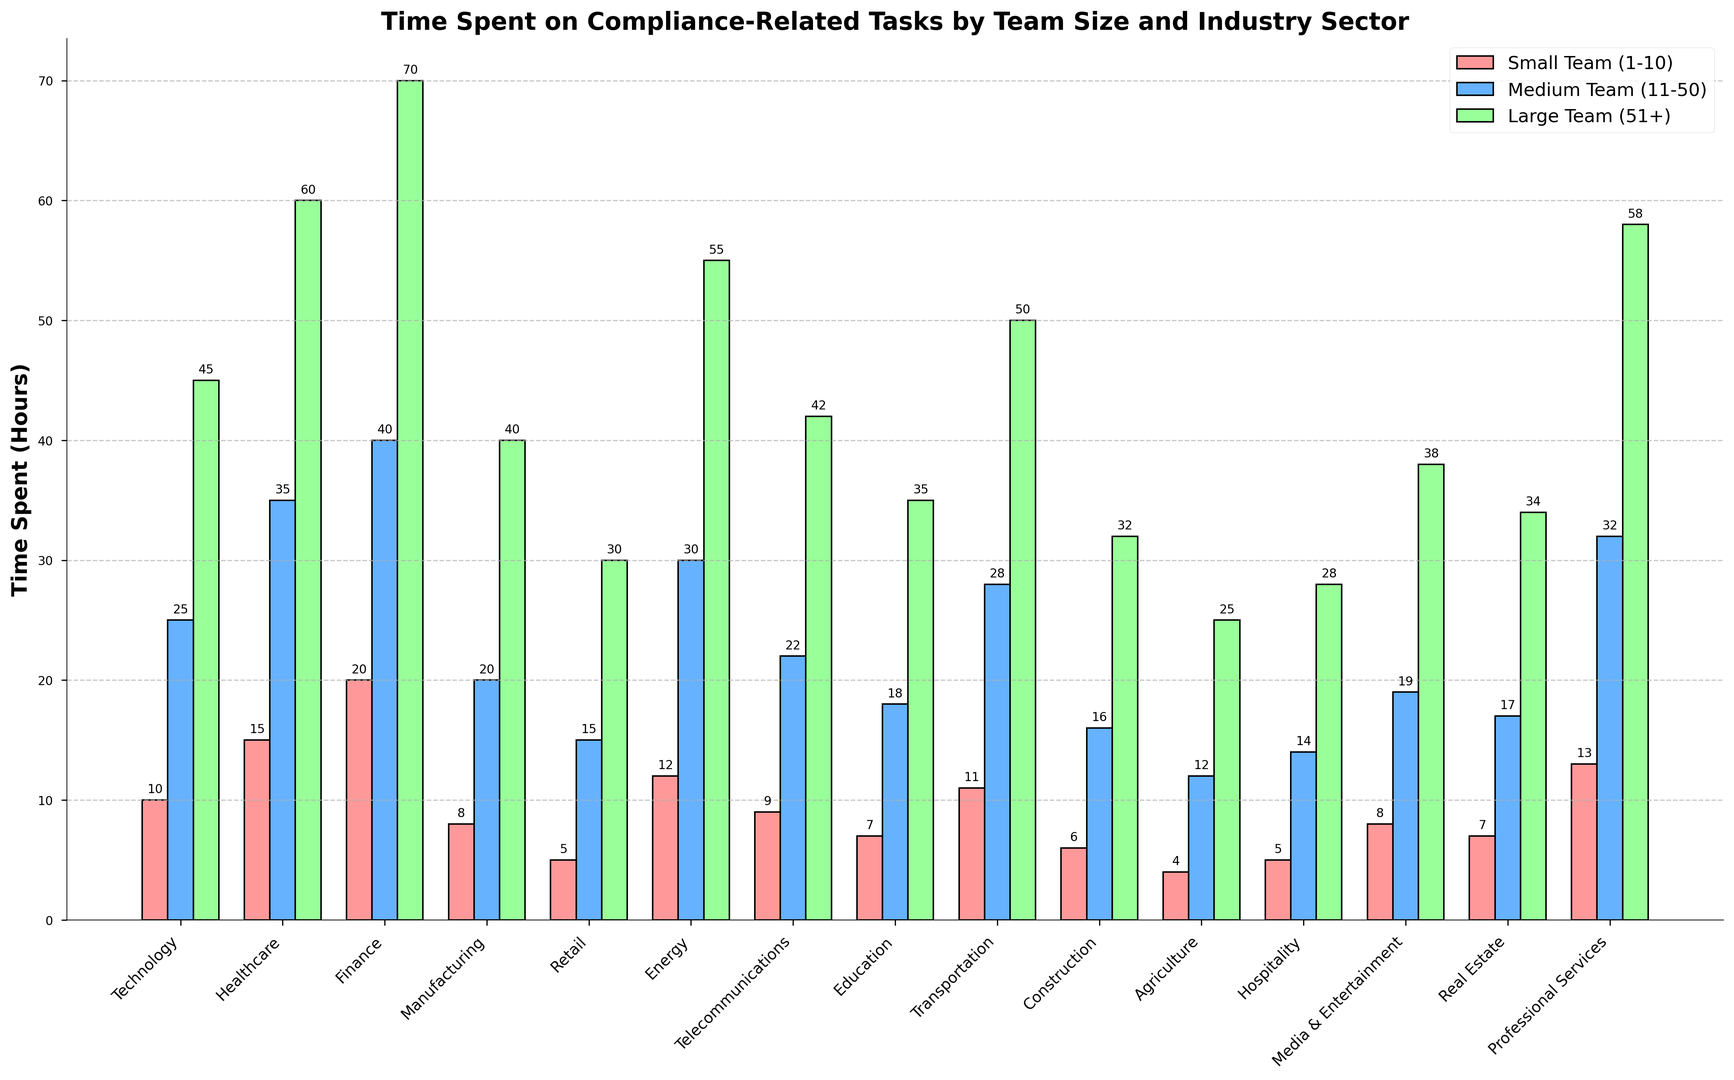What industry sector has the highest time spent on compliance-related tasks for large teams (51+)? In the plot, the bar representing large teams (51+) in the Finance sector is the tallest, indicating the highest time spent on compliance-related tasks.
Answer: Finance Which team size spends the most time on compliance-related tasks in the Retail sector? By comparing the three bars for the Retail sector, the bar representing large teams (51+) is the highest.
Answer: Large Team (51+) What is the difference in time spent on compliance-related tasks between small teams (1-10) and large teams (51+) in the Media & Entertainment sector? Locate the heights of the small teams and large teams' bars in the Media & Entertainment sector and subtract the small teams' bar height (8) from the large teams' bar height (38). Thus, 38 - 8 = 30.
Answer: 30 What is the average time spent on compliance-related tasks across all team sizes in the Telecommunications sector? Sum the bars in the Telecommunications sector: 9 (small) + 22 (medium) + 42 (large), then divide by the number of team sizes (3). The calculation is (9 + 22 + 42) / 3 = 24.33.
Answer: 24.33 Which sector has the least time spent on compliance-related tasks by medium teams (11-50)? Identify the shortest bar among the medium teams' bars, which is the Agriculture sector with a height of 12.
Answer: Agriculture In the Professional Services sector, how much more time does a large team spend on compliance than a small team? Subtract the height of the small teams' bar (13) from the large teams' bar (58) in the Professional Services sector. The calculation is 58 - 13 = 45.
Answer: 45 What's the total time spent on compliance-related tasks by all team sizes in the Construction sector? Sum the heights of all three bars in the Construction sector: 6 (small) + 16 (medium) + 32 (large). The calculation is 6 + 16 + 32 = 54.
Answer: 54 For which sector do small teams (1-10) spend the least time on compliance-related tasks? The shortest bar among the small teams' bars is found in the Agriculture sector with a height of 4.
Answer: Agriculture How much more time do teams in the Energy sector spend on compliance-related tasks compared to teams in the Technology sector across all team sizes? Sum the heights of all bars in both sectors and compare. Energy: 12 (small) + 30 (medium) + 55 (large) = 97. Technology: 10 (small) + 25 (medium) + 45 (large) = 80. The difference is 97 - 80 = 17.
Answer: 17 